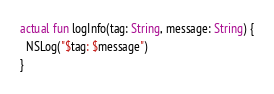Convert code to text. <code><loc_0><loc_0><loc_500><loc_500><_Kotlin_>
actual fun logInfo(tag: String, message: String) {
  NSLog("$tag: $message")
}</code> 